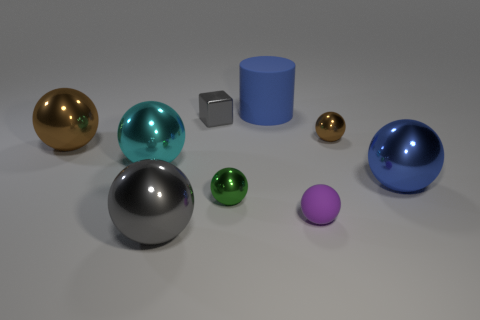Subtract 1 blocks. How many blocks are left? 0 Subtract all tiny brown balls. How many balls are left? 6 Subtract all cubes. How many objects are left? 8 Subtract all large cylinders. Subtract all big brown things. How many objects are left? 7 Add 9 small brown things. How many small brown things are left? 10 Add 6 large blue shiny objects. How many large blue shiny objects exist? 7 Subtract all blue spheres. How many spheres are left? 6 Subtract 0 cyan blocks. How many objects are left? 9 Subtract all brown spheres. Subtract all yellow cylinders. How many spheres are left? 5 Subtract all purple cubes. How many red cylinders are left? 0 